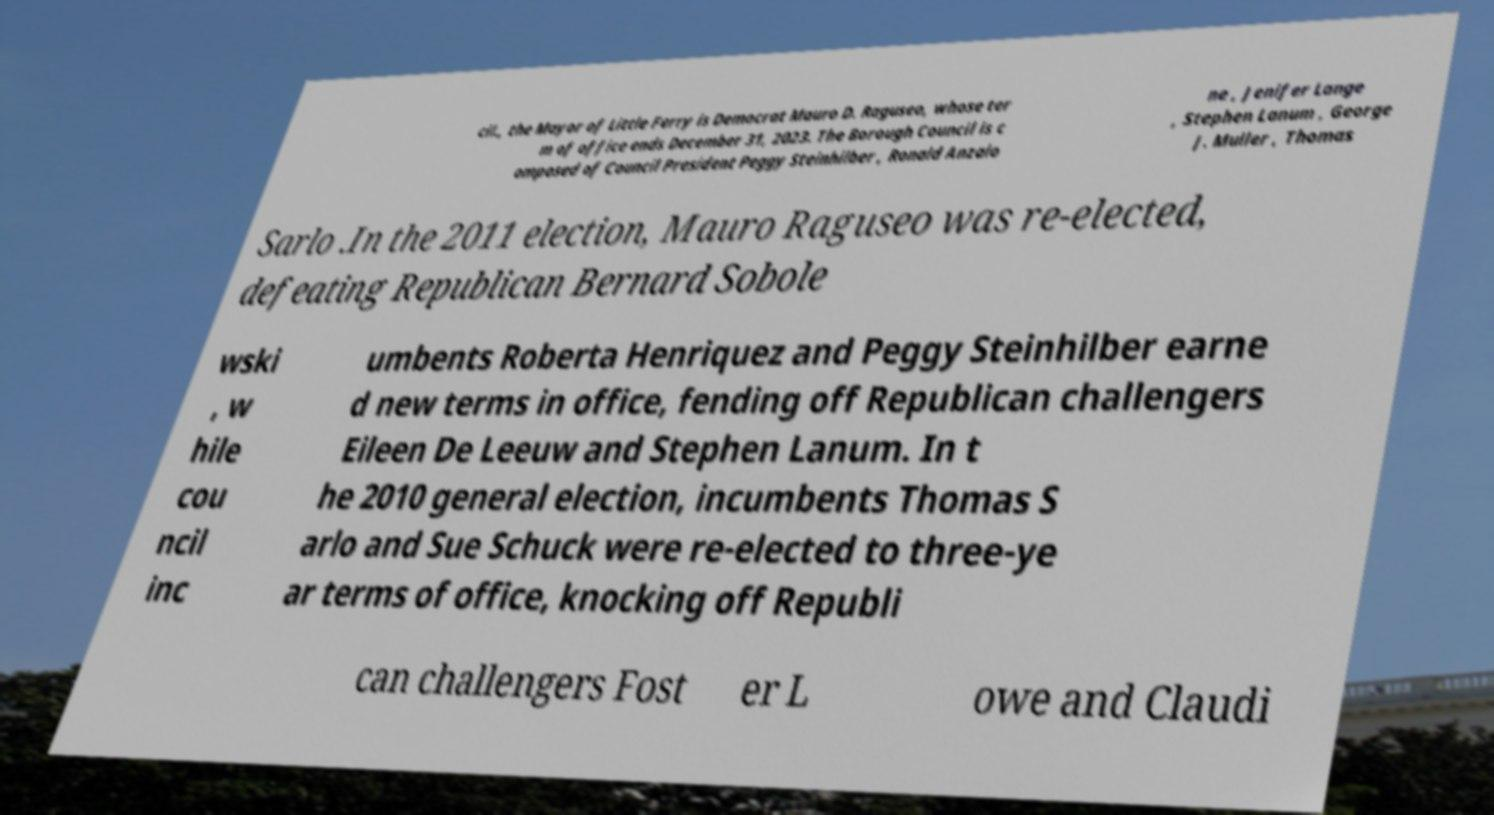For documentation purposes, I need the text within this image transcribed. Could you provide that? cil., the Mayor of Little Ferry is Democrat Mauro D. Raguseo, whose ter m of office ends December 31, 2023. The Borough Council is c omposed of Council President Peggy Steinhilber , Ronald Anzalo ne , Jenifer Lange , Stephen Lanum , George J. Muller , Thomas Sarlo .In the 2011 election, Mauro Raguseo was re-elected, defeating Republican Bernard Sobole wski , w hile cou ncil inc umbents Roberta Henriquez and Peggy Steinhilber earne d new terms in office, fending off Republican challengers Eileen De Leeuw and Stephen Lanum. In t he 2010 general election, incumbents Thomas S arlo and Sue Schuck were re-elected to three-ye ar terms of office, knocking off Republi can challengers Fost er L owe and Claudi 